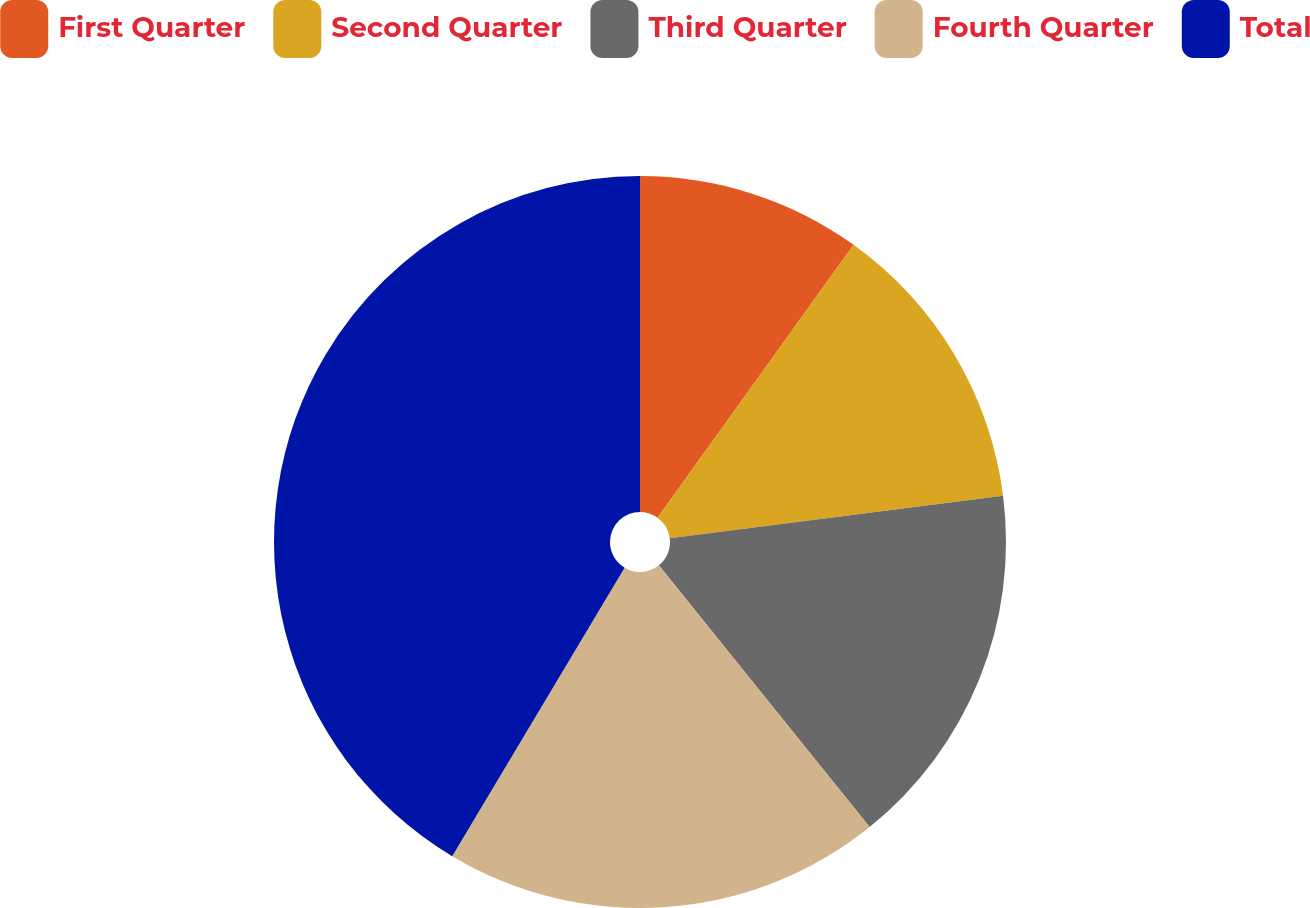Convert chart to OTSL. <chart><loc_0><loc_0><loc_500><loc_500><pie_chart><fcel>First Quarter<fcel>Second Quarter<fcel>Third Quarter<fcel>Fourth Quarter<fcel>Total<nl><fcel>9.92%<fcel>13.07%<fcel>16.22%<fcel>19.37%<fcel>41.43%<nl></chart> 